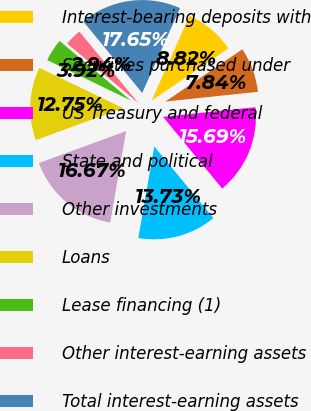<chart> <loc_0><loc_0><loc_500><loc_500><pie_chart><fcel>Interest-bearing deposits with<fcel>Securities purchased under<fcel>US Treasury and federal<fcel>State and political<fcel>Other investments<fcel>Loans<fcel>Lease financing (1)<fcel>Other interest-earning assets<fcel>Total interest-earning assets<nl><fcel>8.82%<fcel>7.84%<fcel>15.68%<fcel>13.72%<fcel>16.66%<fcel>12.74%<fcel>3.92%<fcel>2.94%<fcel>17.64%<nl></chart> 